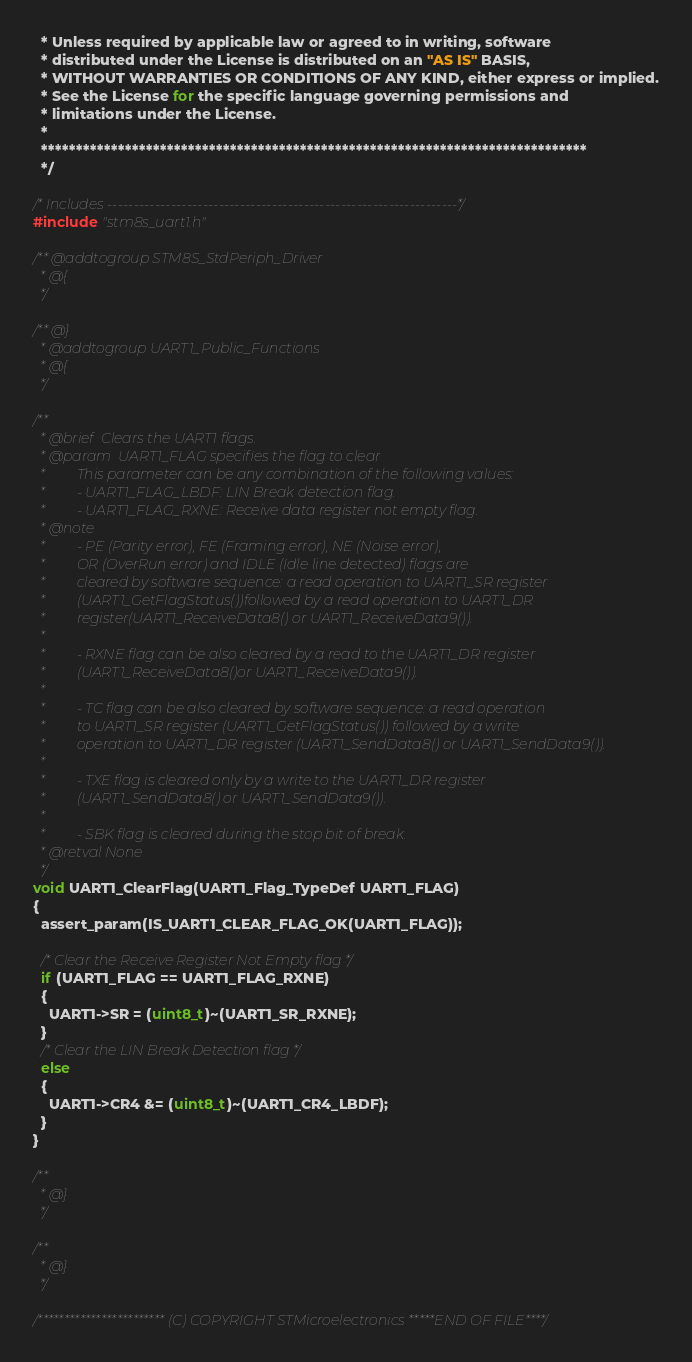<code> <loc_0><loc_0><loc_500><loc_500><_C_>  * Unless required by applicable law or agreed to in writing, software
  * distributed under the License is distributed on an "AS IS" BASIS,
  * WITHOUT WARRANTIES OR CONDITIONS OF ANY KIND, either express or implied.
  * See the License for the specific language governing permissions and
  * limitations under the License.
  *
  ******************************************************************************
  */

/* Includes ------------------------------------------------------------------*/
#include "stm8s_uart1.h"

/** @addtogroup STM8S_StdPeriph_Driver
  * @{
  */

/** @}
  * @addtogroup UART1_Public_Functions
  * @{
  */

/**
  * @brief  Clears the UART1 flags.
  * @param  UART1_FLAG specifies the flag to clear
  *         This parameter can be any combination of the following values:
  *         - UART1_FLAG_LBDF: LIN Break detection flag.
  *         - UART1_FLAG_RXNE: Receive data register not empty flag.
  * @note
  *         - PE (Parity error), FE (Framing error), NE (Noise error), 
  *         OR (OverRun error) and IDLE (Idle line detected) flags are 
  *         cleared by software sequence: a read operation to UART1_SR register
  *         (UART1_GetFlagStatus())followed by a read operation to UART1_DR 
  *         register(UART1_ReceiveData8() or UART1_ReceiveData9()).
  *           
  *         - RXNE flag can be also cleared by a read to the UART1_DR register
  *         (UART1_ReceiveData8()or UART1_ReceiveData9()).
  *           
  *         - TC flag can be also cleared by software sequence: a read operation
  *         to UART1_SR register (UART1_GetFlagStatus()) followed by a write 
  *         operation to UART1_DR register (UART1_SendData8() or UART1_SendData9()).
  *           
  *         - TXE flag is cleared only by a write to the UART1_DR register 
  *         (UART1_SendData8() or UART1_SendData9()).
  *           
  *         - SBK flag is cleared during the stop bit of break.
  * @retval None
  */
void UART1_ClearFlag(UART1_Flag_TypeDef UART1_FLAG)
{
  assert_param(IS_UART1_CLEAR_FLAG_OK(UART1_FLAG));
  
  /* Clear the Receive Register Not Empty flag */
  if (UART1_FLAG == UART1_FLAG_RXNE)
  {
    UART1->SR = (uint8_t)~(UART1_SR_RXNE);
  }
  /* Clear the LIN Break Detection flag */
  else
  {
    UART1->CR4 &= (uint8_t)~(UART1_CR4_LBDF);
  }
}

/**
  * @}
  */

/**
  * @}
  */

/************************ (C) COPYRIGHT STMicroelectronics *****END OF FILE****/
</code> 